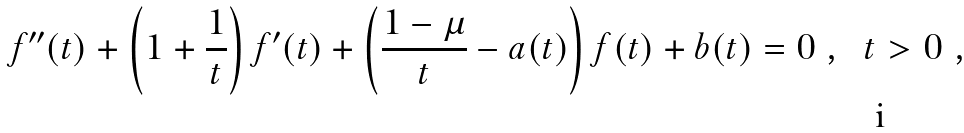<formula> <loc_0><loc_0><loc_500><loc_500>f ^ { \prime \prime } ( t ) + \left ( 1 + \frac { 1 } { t } \right ) f ^ { \prime } ( t ) + \left ( \frac { 1 - \mu } { t } - a ( t ) \right ) f ( t ) + b ( t ) = 0 \ , \ \ t > 0 \ ,</formula> 